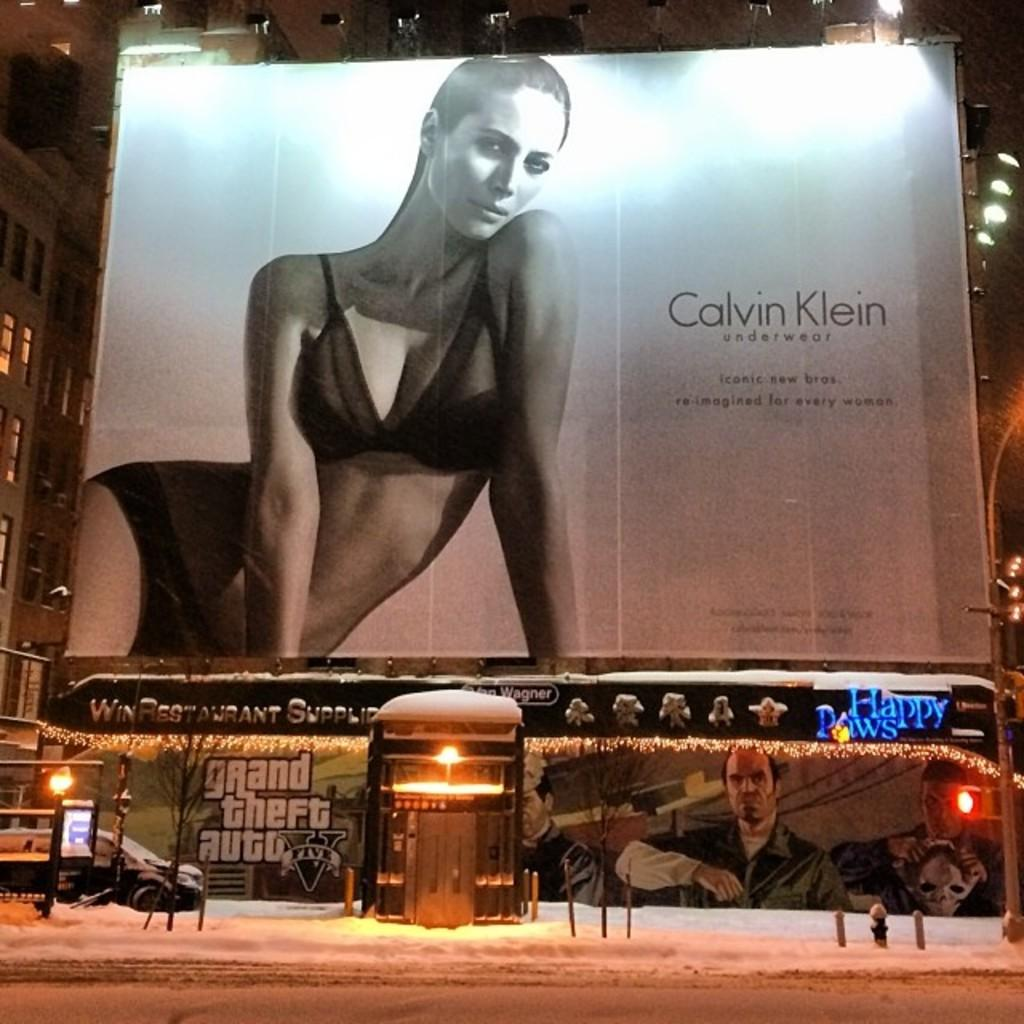<image>
Give a short and clear explanation of the subsequent image. a calvin klein ad that is outside at night 